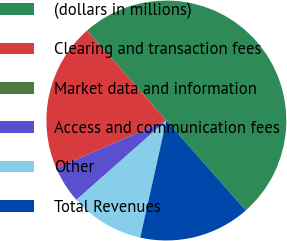Convert chart. <chart><loc_0><loc_0><loc_500><loc_500><pie_chart><fcel>(dollars in millions)<fcel>Clearing and transaction fees<fcel>Market data and information<fcel>Access and communication fees<fcel>Other<fcel>Total Revenues<nl><fcel>50.0%<fcel>20.0%<fcel>0.0%<fcel>5.0%<fcel>10.0%<fcel>15.0%<nl></chart> 